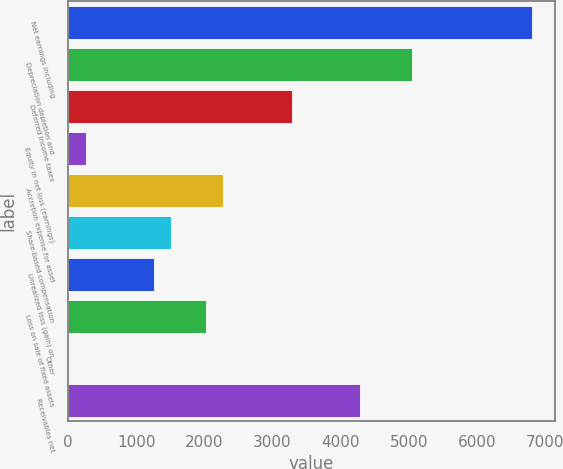<chart> <loc_0><loc_0><loc_500><loc_500><bar_chart><fcel>Net earnings including<fcel>Depreciation depletion and<fcel>Deferred income taxes<fcel>Equity in net loss (earnings)<fcel>Accretion expense for asset<fcel>Share-based compensation<fcel>Unrealized loss (gain) on<fcel>Loss on sale of fixed assets<fcel>Other<fcel>Receivables net<nl><fcel>6800.88<fcel>5039.4<fcel>3277.92<fcel>258.24<fcel>2271.36<fcel>1516.44<fcel>1264.8<fcel>2019.72<fcel>6.6<fcel>4284.48<nl></chart> 